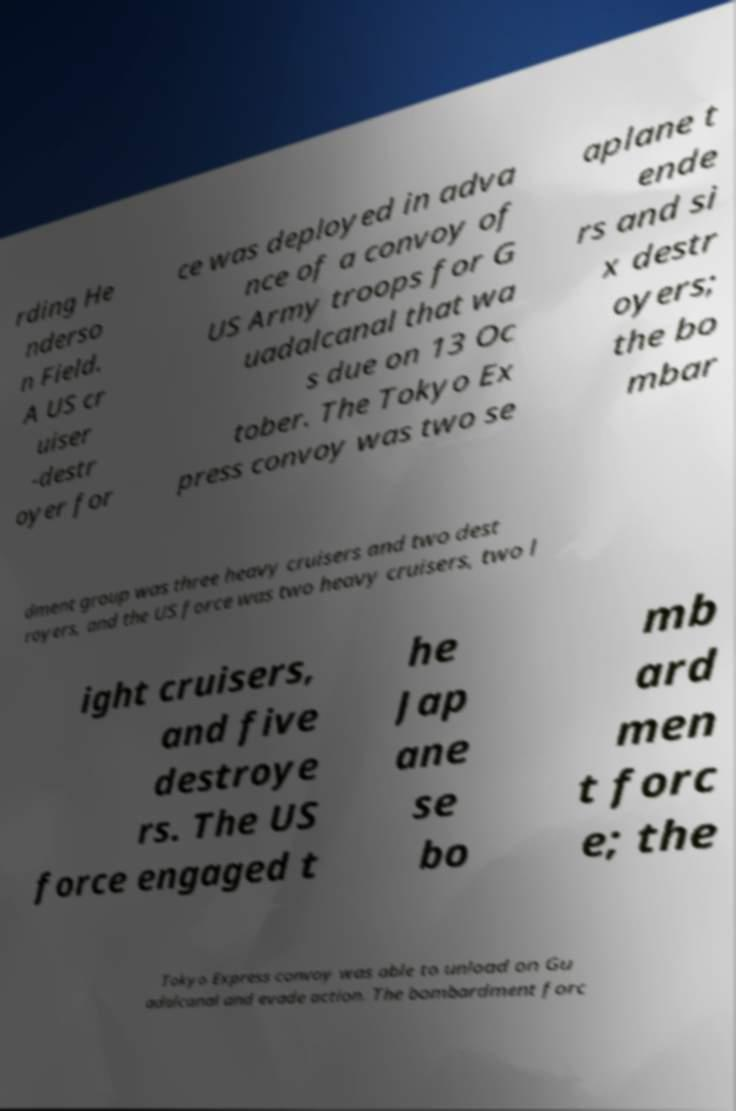Can you read and provide the text displayed in the image?This photo seems to have some interesting text. Can you extract and type it out for me? rding He nderso n Field. A US cr uiser -destr oyer for ce was deployed in adva nce of a convoy of US Army troops for G uadalcanal that wa s due on 13 Oc tober. The Tokyo Ex press convoy was two se aplane t ende rs and si x destr oyers; the bo mbar dment group was three heavy cruisers and two dest royers, and the US force was two heavy cruisers, two l ight cruisers, and five destroye rs. The US force engaged t he Jap ane se bo mb ard men t forc e; the Tokyo Express convoy was able to unload on Gu adalcanal and evade action. The bombardment forc 